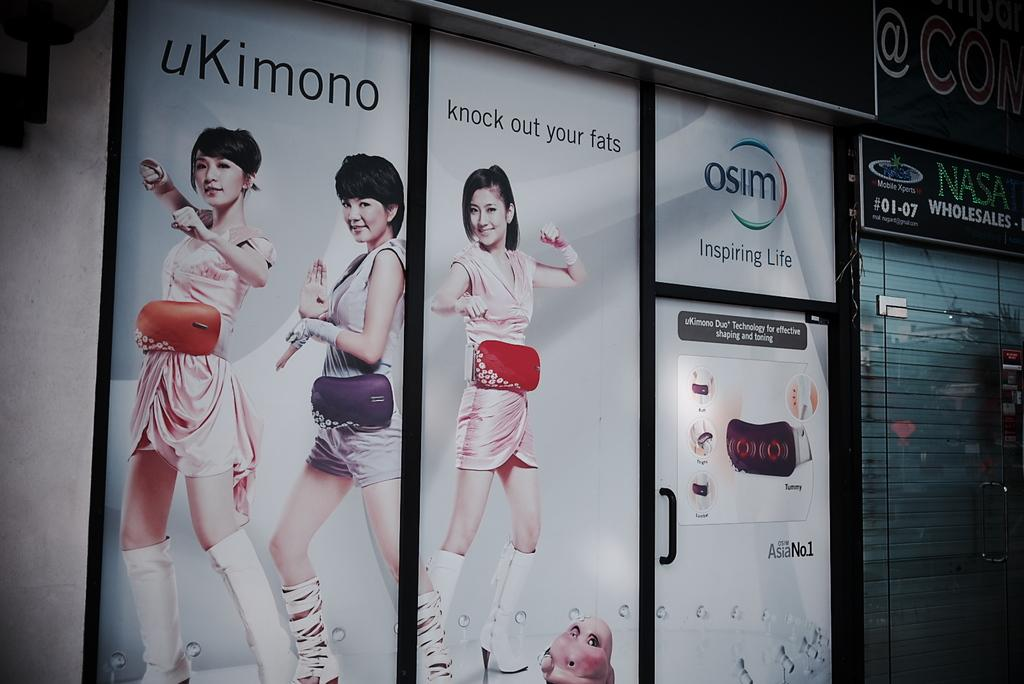What type of structure is present in the image? There is a building in the image. What feature of the building is mentioned in the facts? The building has a door. What can be seen on the walls inside the building? There are pictures of women on the wall, and there is text visible on the wall. What word or theory is the spy trying to decipher in the image? There is no mention of a spy or any word or theory to decipher in the image. 